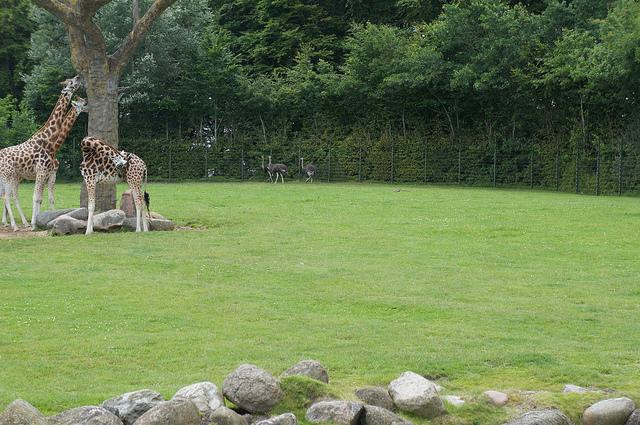The pattern on this animal most closely resembles the pattern on what other animal? Please explain your reasoning. cheetah. The animal most closely resembles a cheetah. 